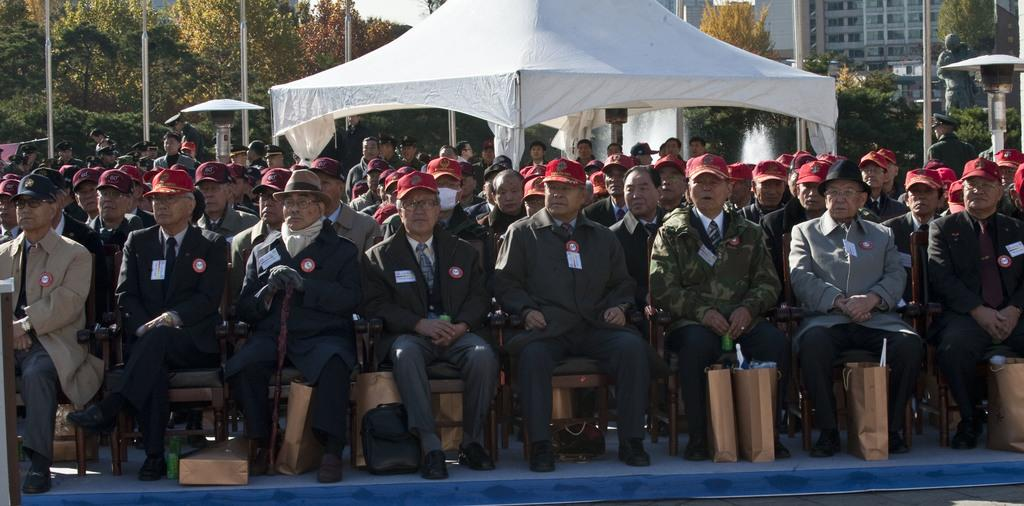How many people are in the group that is visible in the image? There is a group of people in the image, but the exact number is not specified. What are the people wearing on their heads in the image? The people are wearing caps in the image. What are the people doing in the image? The people are sitting on chairs in the image. What items can be seen in the image besides the people and chairs? There are bags, a tent, poles, trees, and buildings with windows in the background of the image. What time of day is it in the image, based on the hour? The provided facts do not mention the time of day or any specific hour in the image, so it cannot be determined from the image. 